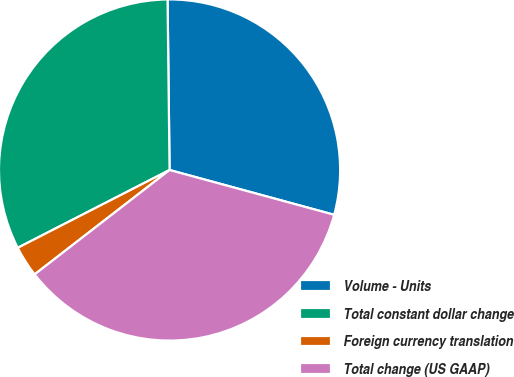<chart> <loc_0><loc_0><loc_500><loc_500><pie_chart><fcel>Volume - Units<fcel>Total constant dollar change<fcel>Foreign currency translation<fcel>Total change (US GAAP)<nl><fcel>29.41%<fcel>32.35%<fcel>2.94%<fcel>35.29%<nl></chart> 